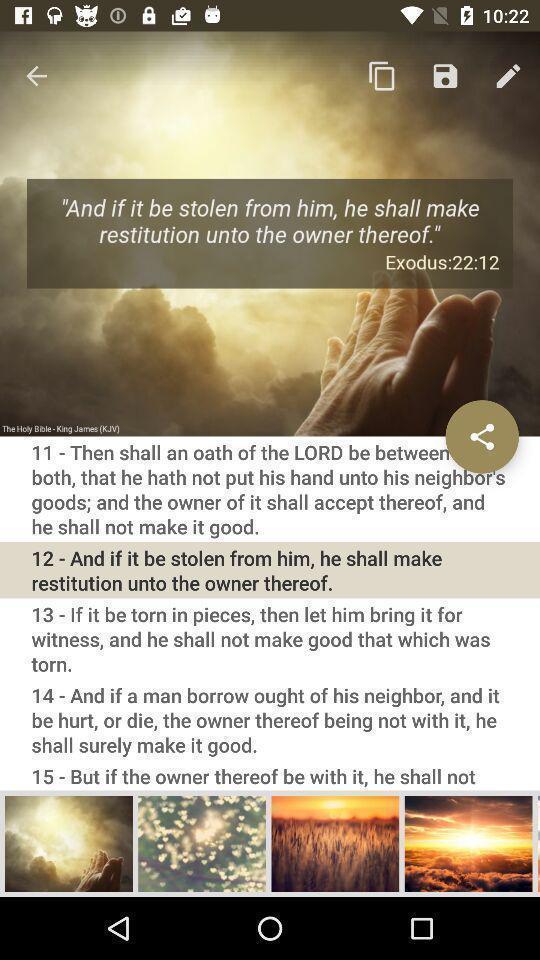Give me a summary of this screen capture. Page that displaying bible application. 